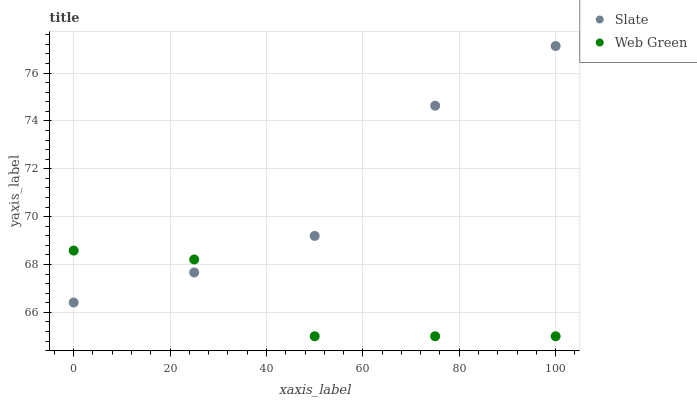Does Web Green have the minimum area under the curve?
Answer yes or no. Yes. Does Slate have the maximum area under the curve?
Answer yes or no. Yes. Does Web Green have the maximum area under the curve?
Answer yes or no. No. Is Web Green the smoothest?
Answer yes or no. Yes. Is Slate the roughest?
Answer yes or no. Yes. Is Web Green the roughest?
Answer yes or no. No. Does Web Green have the lowest value?
Answer yes or no. Yes. Does Slate have the highest value?
Answer yes or no. Yes. Does Web Green have the highest value?
Answer yes or no. No. Does Web Green intersect Slate?
Answer yes or no. Yes. Is Web Green less than Slate?
Answer yes or no. No. Is Web Green greater than Slate?
Answer yes or no. No. 